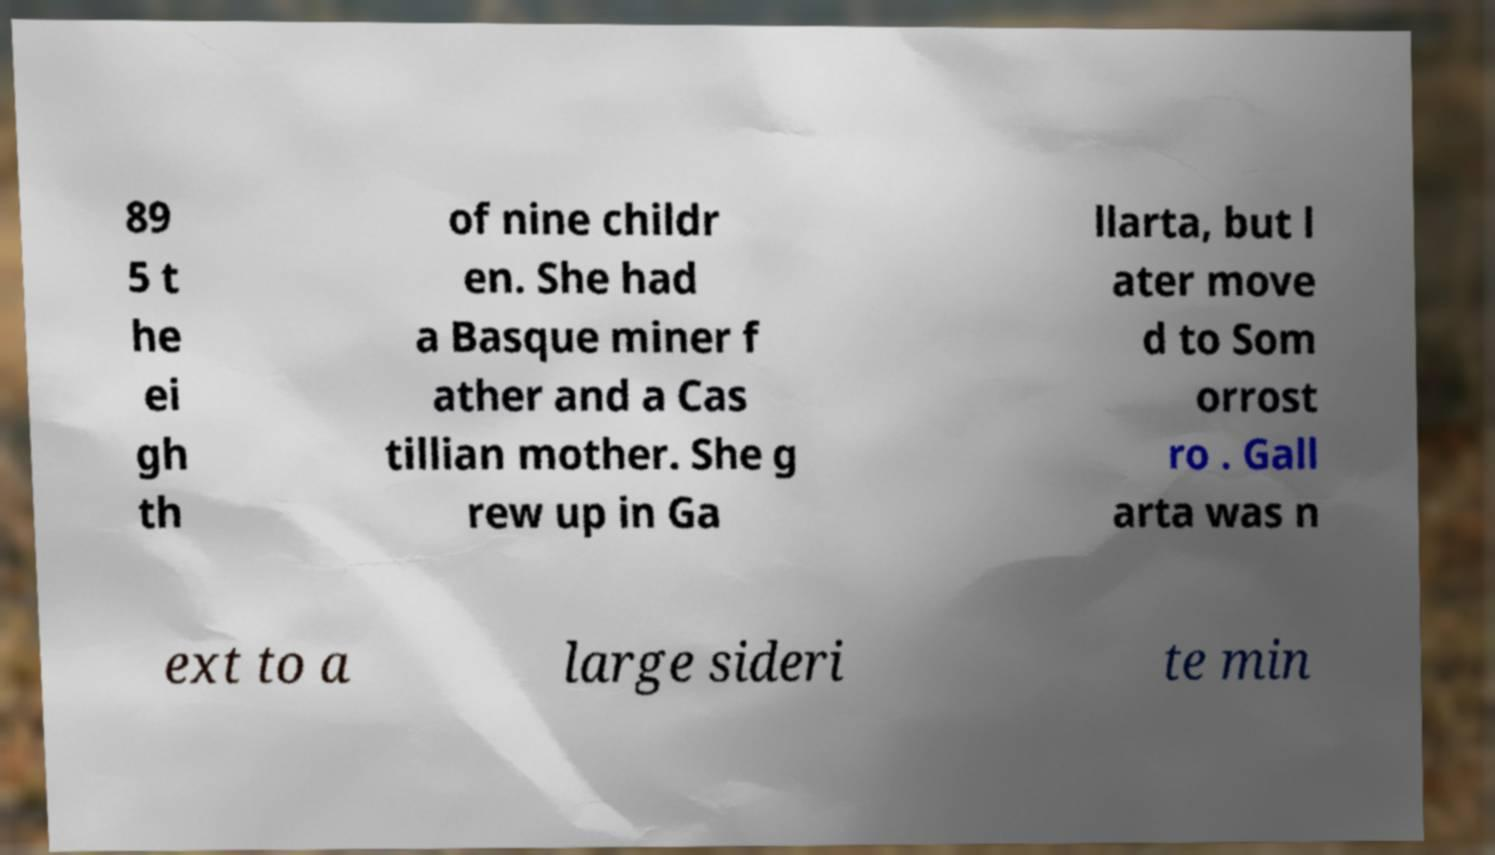I need the written content from this picture converted into text. Can you do that? 89 5 t he ei gh th of nine childr en. She had a Basque miner f ather and a Cas tillian mother. She g rew up in Ga llarta, but l ater move d to Som orrost ro . Gall arta was n ext to a large sideri te min 